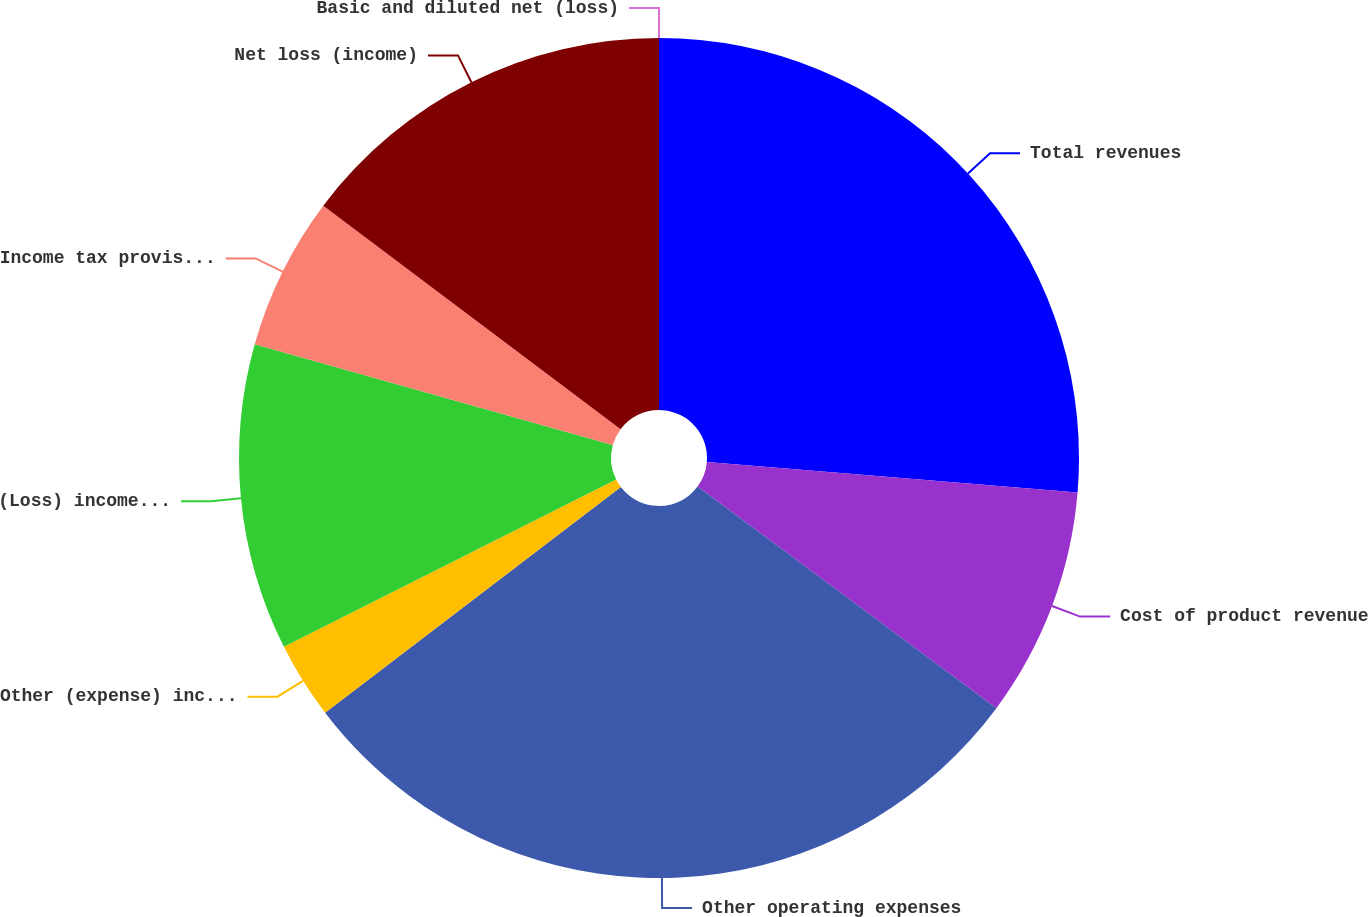Convert chart to OTSL. <chart><loc_0><loc_0><loc_500><loc_500><pie_chart><fcel>Total revenues<fcel>Cost of product revenue<fcel>Other operating expenses<fcel>Other (expense) income net<fcel>(Loss) income before income<fcel>Income tax provision (benefit)<fcel>Net loss (income)<fcel>Basic and diluted net (loss)<nl><fcel>26.31%<fcel>8.84%<fcel>29.47%<fcel>2.95%<fcel>11.79%<fcel>5.89%<fcel>14.74%<fcel>0.0%<nl></chart> 